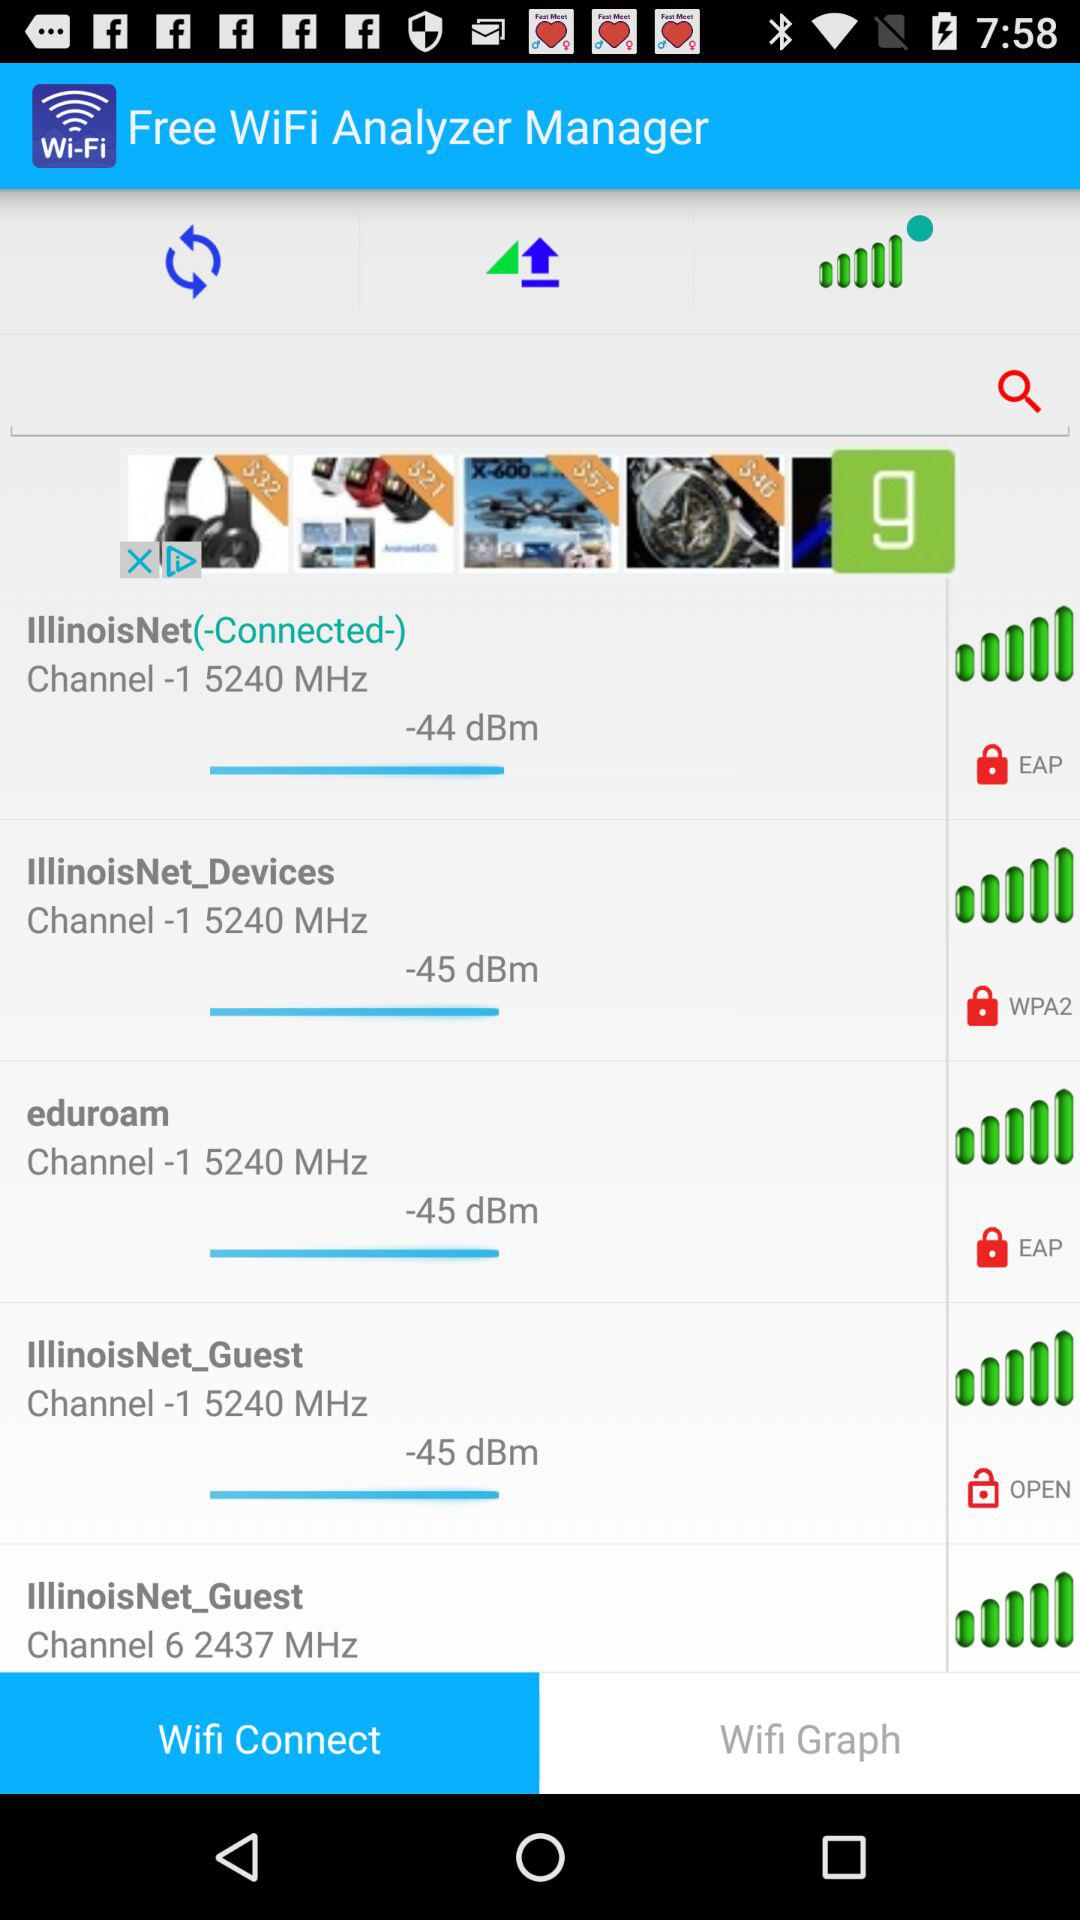What is the channel number for "eduroam"? The channel number is 1. 